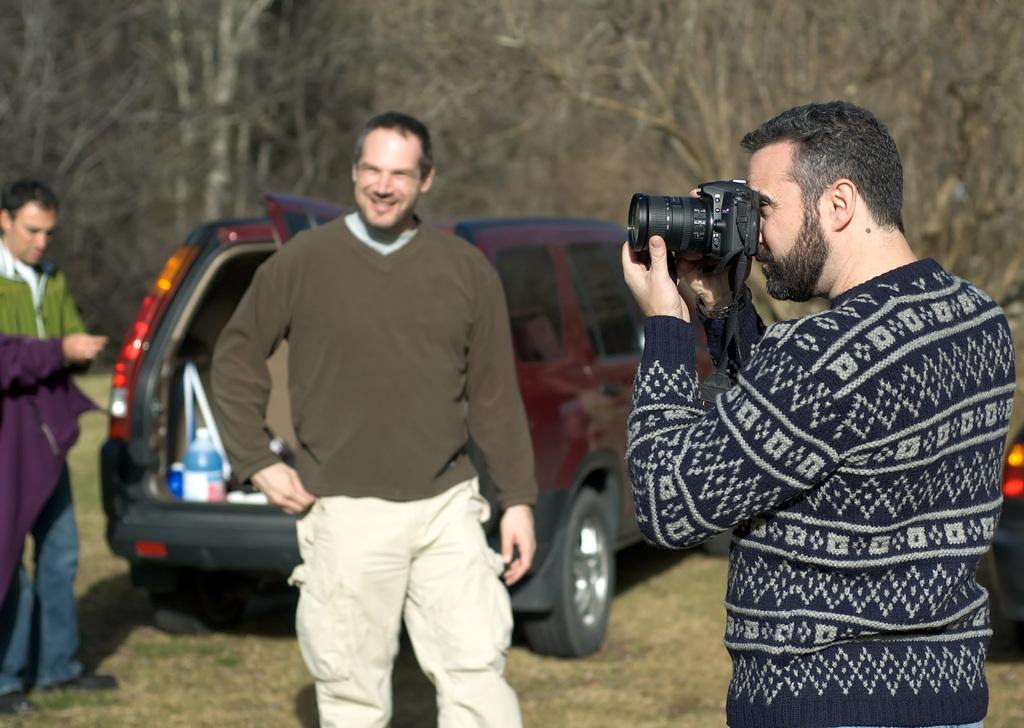What is the person in the foreground of the image doing? The person in the foreground is standing and holding a camera. Who is standing beside the person holding the camera? There is another person standing beside the first person. What is the expression of the second person? The second person is smiling. What can be seen in the background of the image? There is a car and trees visible in the image. What type of army is marching through the image? There is no army present in the image; it features two people and a camera. Can you describe the cloud formation in the image? There are: There is no cloud formation visible in the image. 